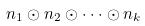Convert formula to latex. <formula><loc_0><loc_0><loc_500><loc_500>n _ { 1 } \odot n _ { 2 } \odot \cdot \cdot \cdot \odot n _ { k }</formula> 